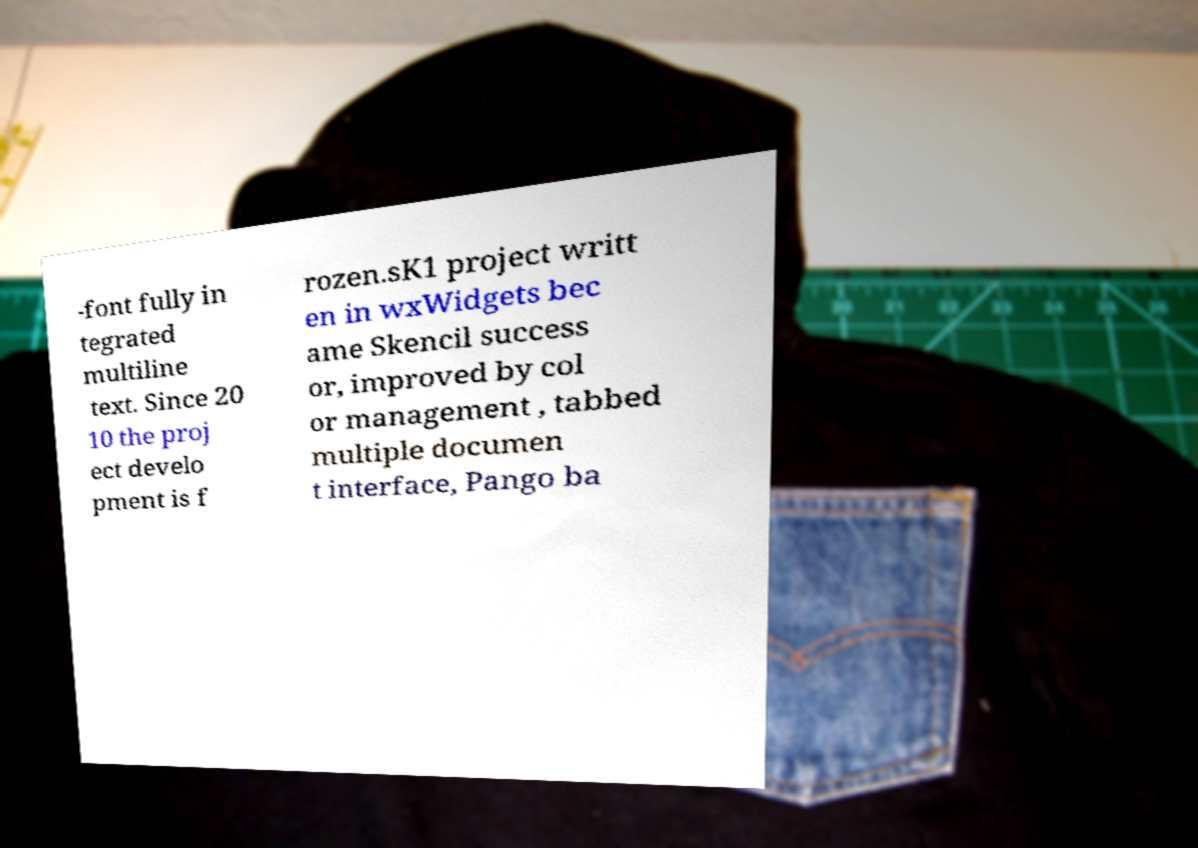Please identify and transcribe the text found in this image. -font fully in tegrated multiline text. Since 20 10 the proj ect develo pment is f rozen.sK1 project writt en in wxWidgets bec ame Skencil success or, improved by col or management , tabbed multiple documen t interface, Pango ba 